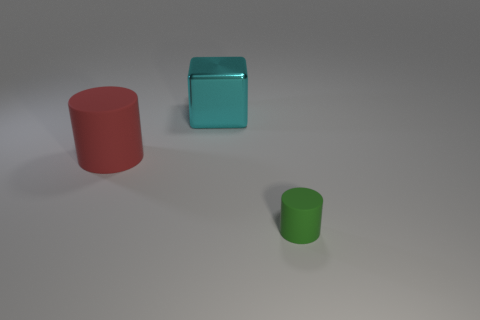There is a cyan cube; are there any cyan things behind it?
Offer a terse response. No. Are there any big red things that have the same material as the small green cylinder?
Give a very brief answer. Yes. How many cylinders are either tiny objects or yellow matte things?
Your response must be concise. 1. Are there more large cyan shiny things in front of the cyan object than cyan blocks in front of the large red thing?
Your response must be concise. No. There is a cylinder that is made of the same material as the tiny object; what size is it?
Keep it short and to the point. Large. How many objects are matte cylinders in front of the red rubber cylinder or large shiny objects?
Ensure brevity in your answer.  2. There is a big object on the right side of the large red cylinder; is it the same color as the tiny cylinder?
Offer a very short reply. No. There is another thing that is the same shape as the green thing; what size is it?
Your answer should be very brief. Large. The thing in front of the rubber cylinder behind the object that is on the right side of the cyan cube is what color?
Make the answer very short. Green. Is the material of the cube the same as the large red cylinder?
Provide a short and direct response. No. 